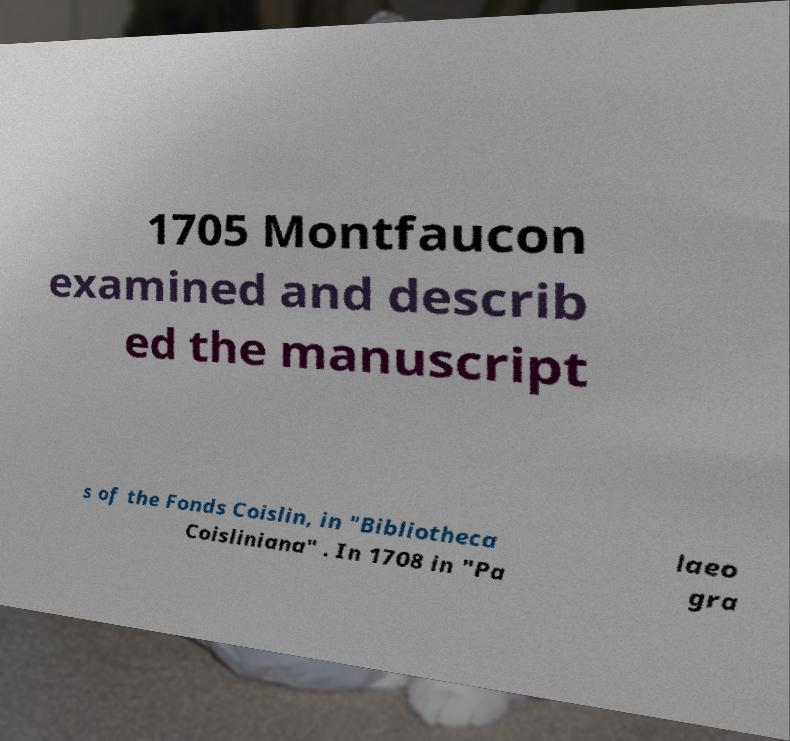Can you read and provide the text displayed in the image?This photo seems to have some interesting text. Can you extract and type it out for me? 1705 Montfaucon examined and describ ed the manuscript s of the Fonds Coislin, in "Bibliotheca Coisliniana" . In 1708 in "Pa laeo gra 